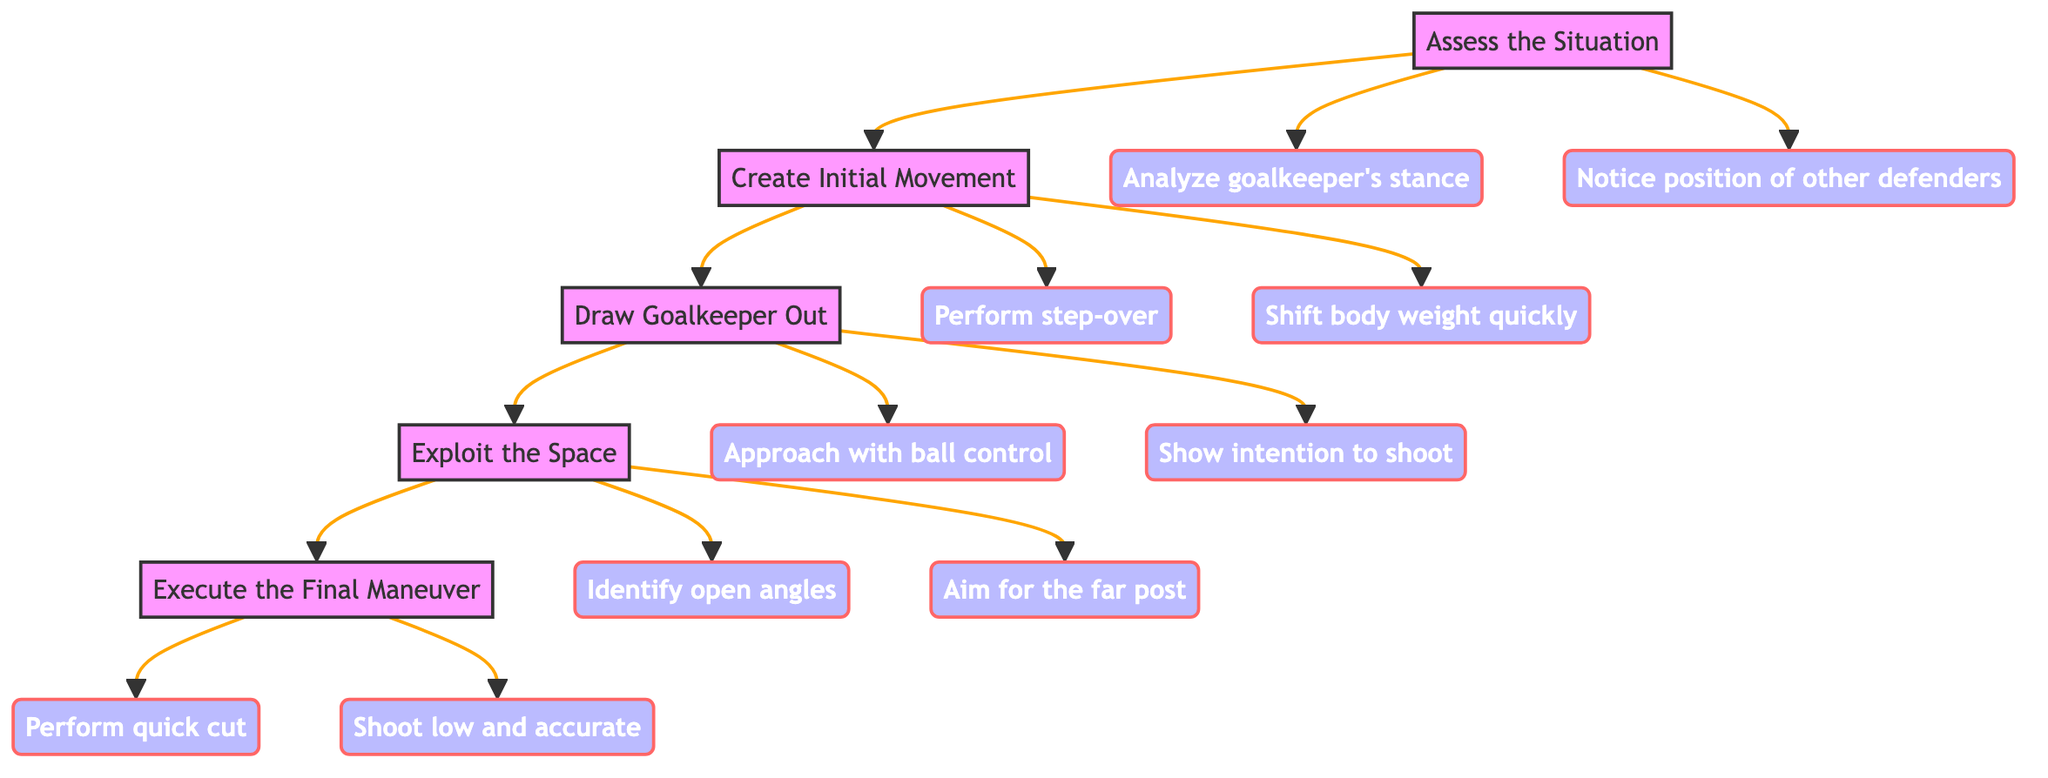What is the first step in the diagram? The first step in the flowchart is labeled "Assess the Situation," as indicated at the top of the diagram.
Answer: Assess the Situation How many steps are there in total? The diagram contains a total of five main steps, numbered 1 to 5.
Answer: Five What action accompanies the step "Create Initial Movement"? The actions listed under the step "Create Initial Movement" include "Perform step-over to mislead goalkeeper" and "Shift body weight quickly to the left or right."
Answer: Perform step-over to mislead goalkeeper What is the relationship between "Draw Goalkeeper Out" and "Exploit the Space"? "Draw Goalkeeper Out" directly leads to "Exploit the Space," indicating that exploiting the space is the next step after engaging the goalkeeper.
Answer: Draw Goalkeeper Out leads to Exploit the Space What are the final actions in the process? The last two actions under "Execute the Final Maneuver" are "Perform a quick cut to change direction" and "Shoot low and accurate."
Answer: Perform a quick cut to change direction, Shoot low and accurate Which step focuses on using created space to one's advantage? The step that emphasizes using created space is labeled "Exploit the Space."
Answer: Exploit the Space How many actions are associated with the "Assess the Situation" step? There are two actions associated with the "Assess the Situation" step, namely "Analyze goalkeeper's stance" and "Notice position of other defenders."
Answer: Two actions Which step includes the action of aiming for the far post? The action of aiming for the far post appears in the "Exploit the Space" step, which indicates the objective during that phase.
Answer: Exploit the Space What action is suggested to distract the goalkeeper? The action suggested to distract the goalkeeper is "Show intention to shoot," which is part of the "Draw Goalkeeper Out" step.
Answer: Show intention to shoot 